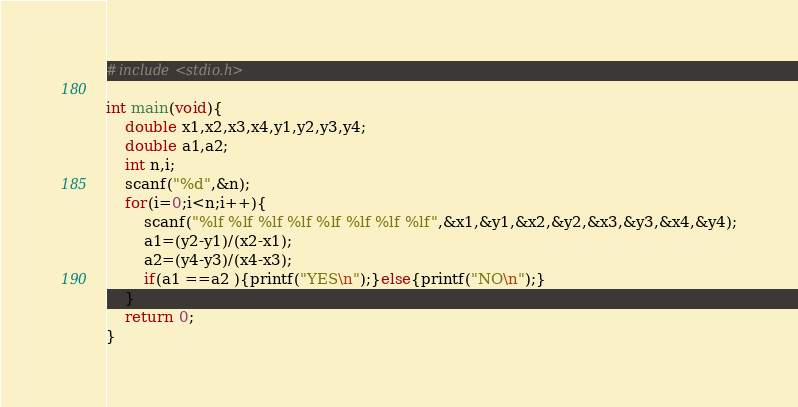Convert code to text. <code><loc_0><loc_0><loc_500><loc_500><_C_>#include<stdio.h>

int main(void){
	double x1,x2,x3,x4,y1,y2,y3,y4;
	double a1,a2;
	int n,i;
	scanf("%d",&n);
	for(i=0;i<n;i++){
		scanf("%lf %lf %lf %lf %lf %lf %lf %lf",&x1,&y1,&x2,&y2,&x3,&y3,&x4,&y4);
		a1=(y2-y1)/(x2-x1);
		a2=(y4-y3)/(x4-x3);
		if(a1 ==a2 ){printf("YES\n");}else{printf("NO\n");}
	}
	return 0;
}</code> 